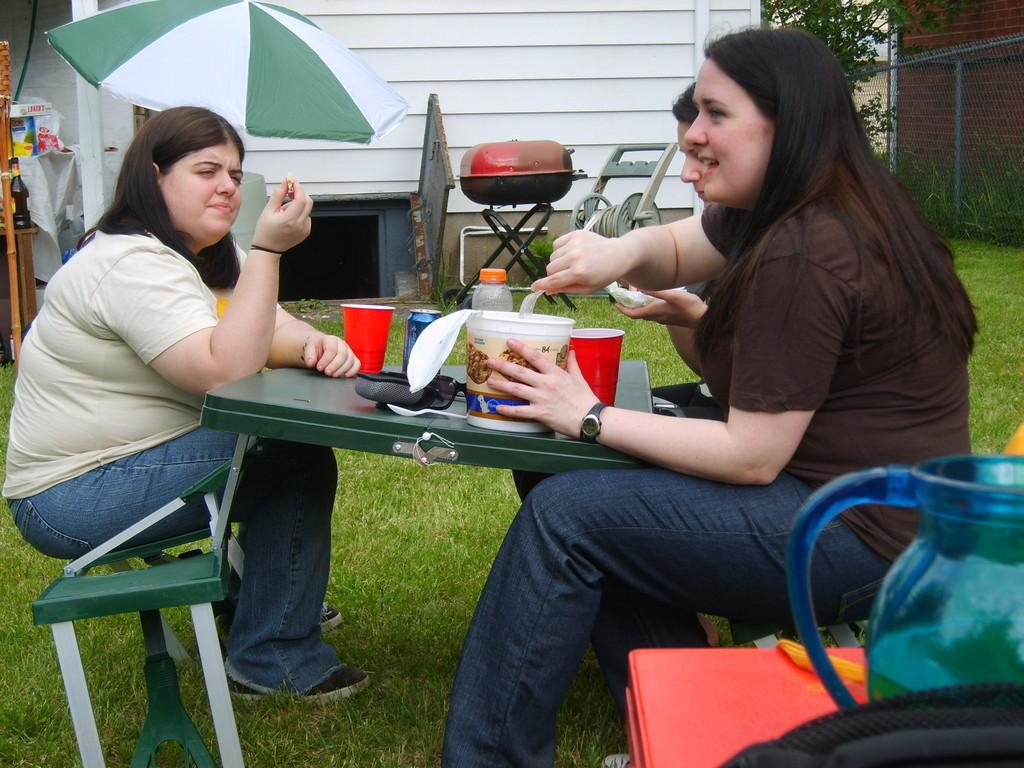How many women are in the image? There are three women in the image. What are the women doing in the image? The women are sitting on either side of a table. What is in front of the women? There is a table in front of the women. What is on the table? The table has some eatables on it. What can be seen on the ground in the image? The ground is covered in greenery. What type of screw can be seen on the table in the image? There is no screw present on the table in the image. How many bells are hanging from the tree in the image? There is no tree or bells present in the image. 